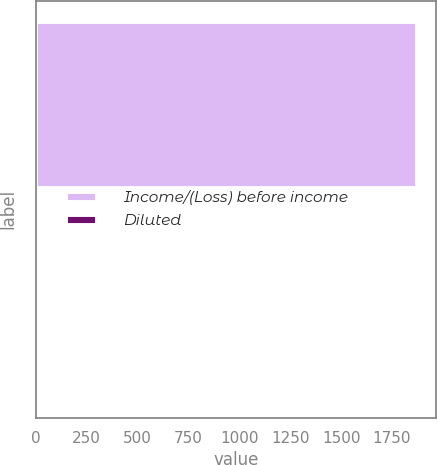<chart> <loc_0><loc_0><loc_500><loc_500><bar_chart><fcel>Income/(Loss) before income<fcel>Diluted<nl><fcel>1872<fcel>0.63<nl></chart> 